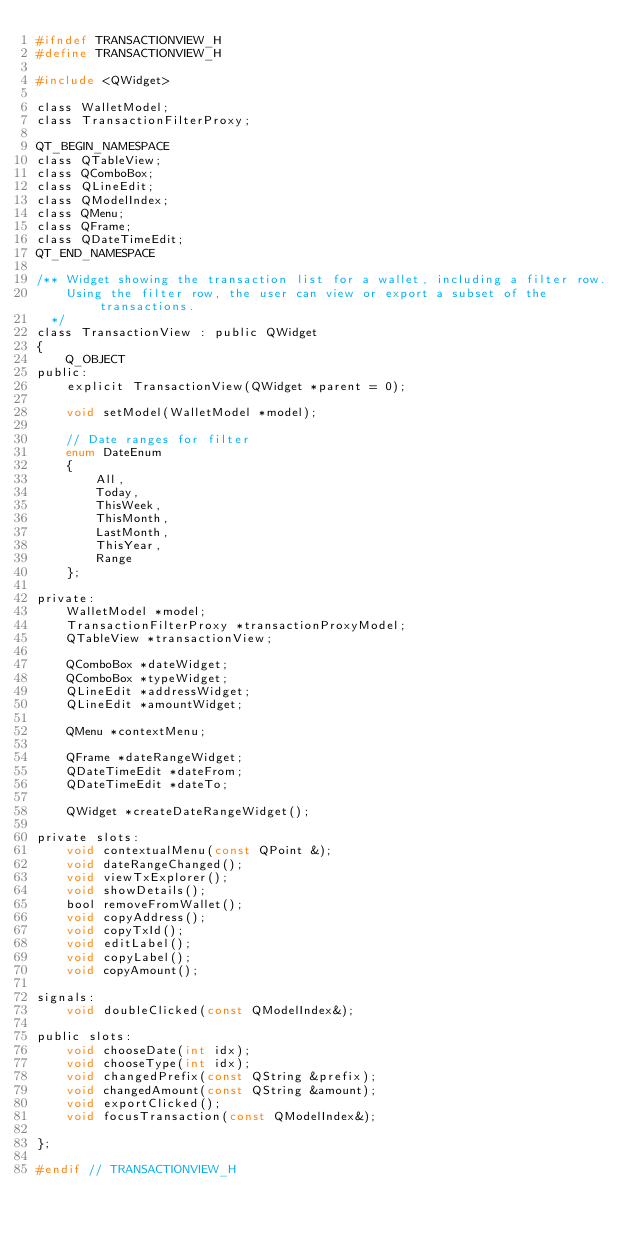<code> <loc_0><loc_0><loc_500><loc_500><_C_>#ifndef TRANSACTIONVIEW_H
#define TRANSACTIONVIEW_H

#include <QWidget>

class WalletModel;
class TransactionFilterProxy;

QT_BEGIN_NAMESPACE
class QTableView;
class QComboBox;
class QLineEdit;
class QModelIndex;
class QMenu;
class QFrame;
class QDateTimeEdit;
QT_END_NAMESPACE

/** Widget showing the transaction list for a wallet, including a filter row.
    Using the filter row, the user can view or export a subset of the transactions.
  */
class TransactionView : public QWidget
{
    Q_OBJECT
public:
    explicit TransactionView(QWidget *parent = 0);

    void setModel(WalletModel *model);

    // Date ranges for filter
    enum DateEnum
    {
        All,
        Today,
        ThisWeek,
        ThisMonth,
        LastMonth,
        ThisYear,
        Range
    };

private:
    WalletModel *model;
    TransactionFilterProxy *transactionProxyModel;
    QTableView *transactionView;

    QComboBox *dateWidget;
    QComboBox *typeWidget;
    QLineEdit *addressWidget;
    QLineEdit *amountWidget;

    QMenu *contextMenu;

    QFrame *dateRangeWidget;
    QDateTimeEdit *dateFrom;
    QDateTimeEdit *dateTo;

    QWidget *createDateRangeWidget();

private slots:
    void contextualMenu(const QPoint &);
    void dateRangeChanged();
    void viewTxExplorer();
    void showDetails();
    bool removeFromWallet();
    void copyAddress();
    void copyTxId();
    void editLabel();
    void copyLabel();
    void copyAmount();

signals:
    void doubleClicked(const QModelIndex&);

public slots:
    void chooseDate(int idx);
    void chooseType(int idx);
    void changedPrefix(const QString &prefix);
    void changedAmount(const QString &amount);
    void exportClicked();
    void focusTransaction(const QModelIndex&);

};

#endif // TRANSACTIONVIEW_H
</code> 